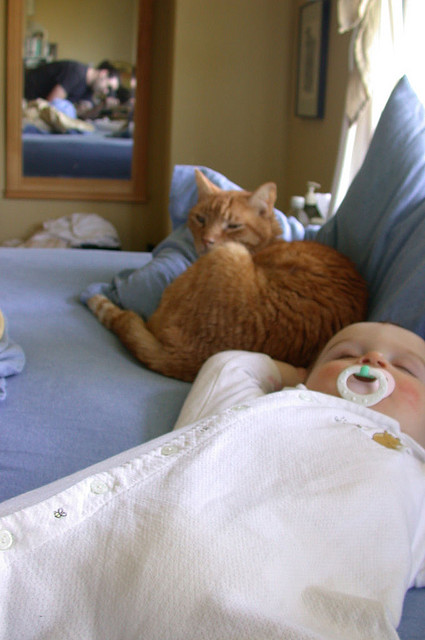<image>What is tribal? The term 'tribal' is ambiguous without context. What is tribal? I don't know what tribal is. It can be anything. 